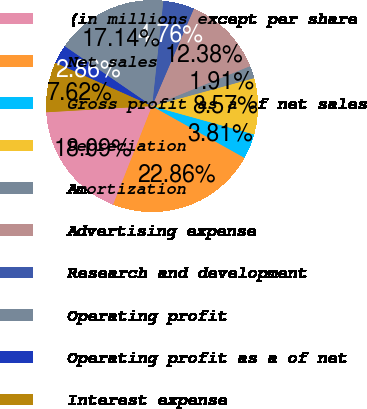Convert chart. <chart><loc_0><loc_0><loc_500><loc_500><pie_chart><fcel>(in millions except per share<fcel>Net sales<fcel>Gross profit as a of net sales<fcel>Depreciation<fcel>Amortization<fcel>Advertising expense<fcel>Research and development<fcel>Operating profit<fcel>Operating profit as a of net<fcel>Interest expense<nl><fcel>18.09%<fcel>22.86%<fcel>3.81%<fcel>8.57%<fcel>1.91%<fcel>12.38%<fcel>4.76%<fcel>17.14%<fcel>2.86%<fcel>7.62%<nl></chart> 